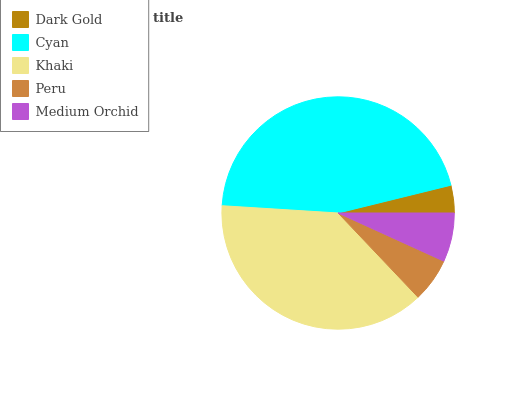Is Dark Gold the minimum?
Answer yes or no. Yes. Is Cyan the maximum?
Answer yes or no. Yes. Is Khaki the minimum?
Answer yes or no. No. Is Khaki the maximum?
Answer yes or no. No. Is Cyan greater than Khaki?
Answer yes or no. Yes. Is Khaki less than Cyan?
Answer yes or no. Yes. Is Khaki greater than Cyan?
Answer yes or no. No. Is Cyan less than Khaki?
Answer yes or no. No. Is Medium Orchid the high median?
Answer yes or no. Yes. Is Medium Orchid the low median?
Answer yes or no. Yes. Is Khaki the high median?
Answer yes or no. No. Is Dark Gold the low median?
Answer yes or no. No. 